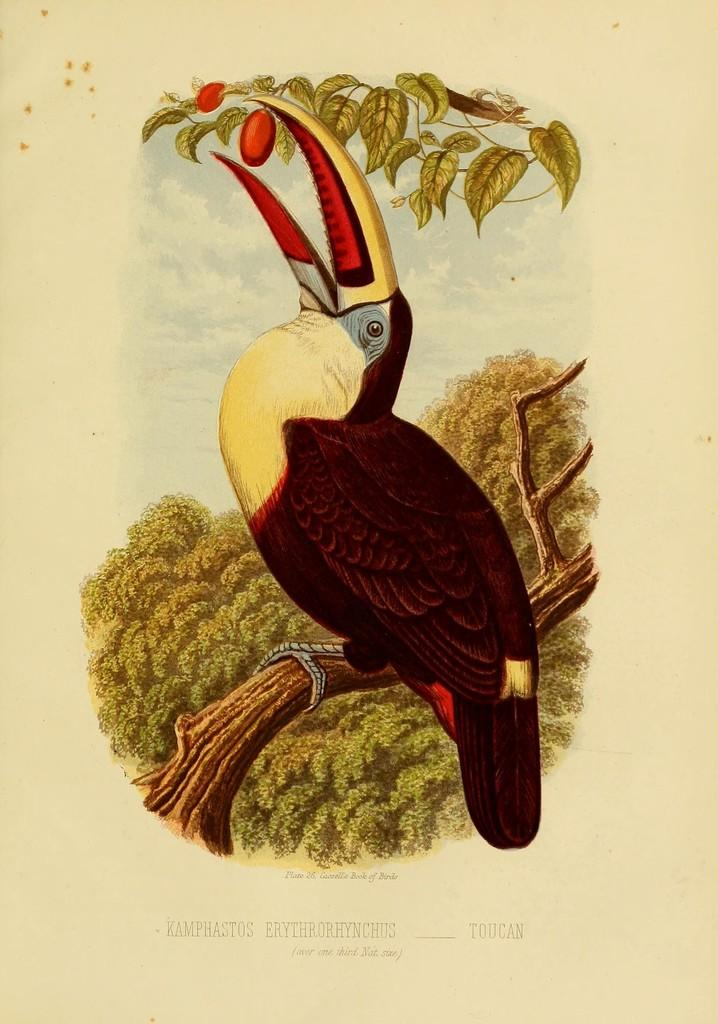What is the main subject in the foreground of the image? There is an animated bird on a branch in the foreground of the image. What can be seen in the background of the image? There are trees and the sky visible in the background of the image. How many eggs are on the desk in the image? There is no desk present in the image, and therefore no eggs can be found on it. 